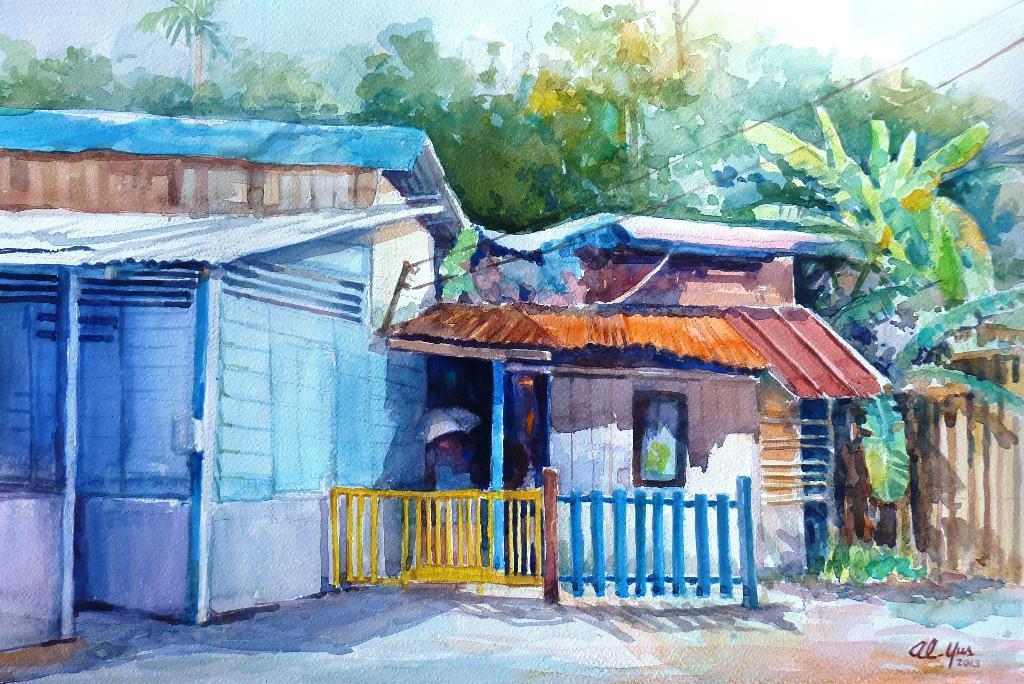Can you describe this image briefly? In this picture I can see there is painting and there are few buildings, trees and the sky is clear. 